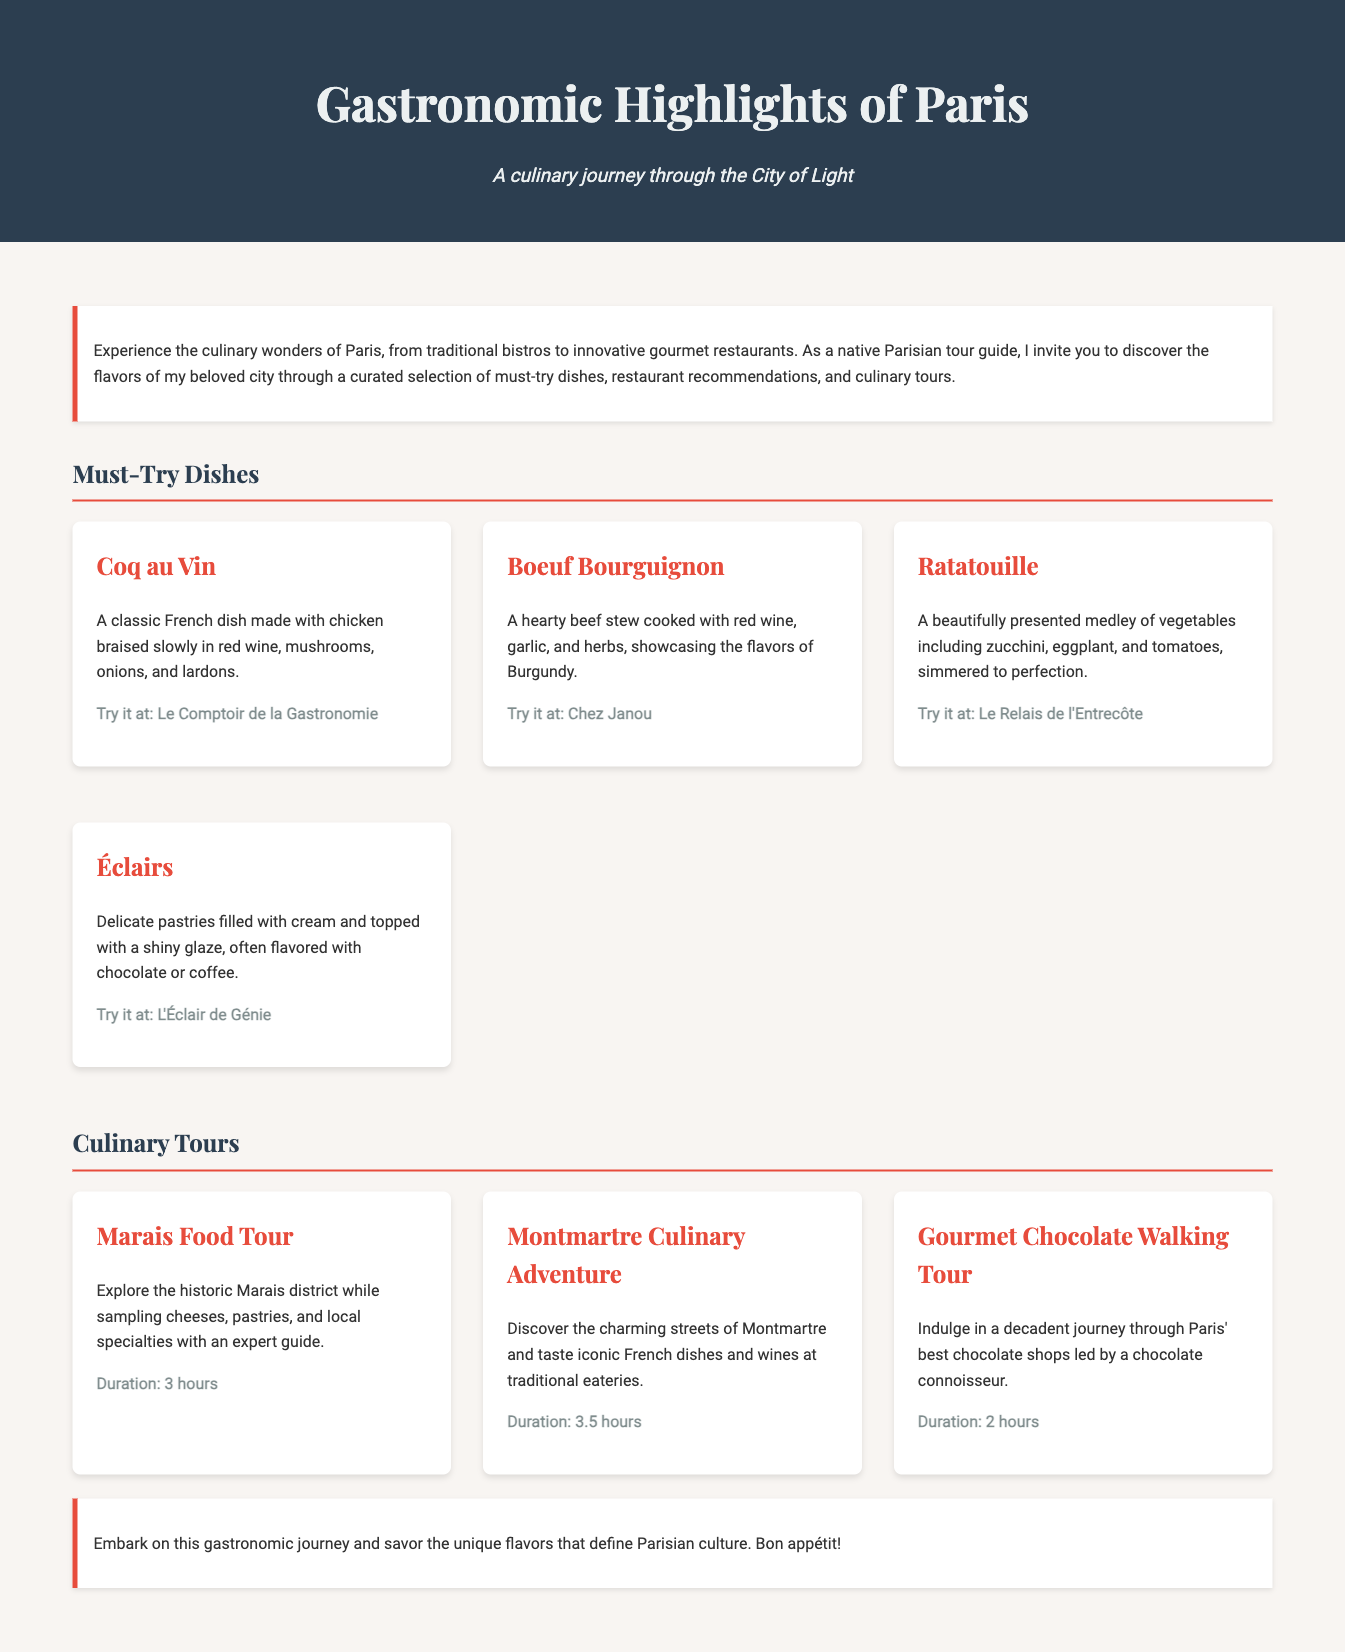What is the title of the document? The title of the document is indicated at the top and is "Gastronomic Highlights of Paris."
Answer: Gastronomic Highlights of Paris What dish is recommended at Le Comptoir de la Gastronomie? The dish recommended at Le Comptoir de la Gastronomie is mentioned as "Coq au Vin."
Answer: Coq au Vin How long is the Montmartre Culinary Adventure tour? The length of the Montmartre Culinary Adventure tour is explicitly stated in the document as "3.5 hours."
Answer: 3.5 hours What type of tour explores the Marais district? The type of tour that explores the Marais district is specified as the "Marais Food Tour."
Answer: Marais Food Tour Which dish includes eggplant and tomatoes? The dish that includes eggplant and tomatoes is described as "Ratatouille."
Answer: Ratatouille What is the duration of the Gourmet Chocolate Walking Tour? The duration of the Gourmet Chocolate Walking Tour is given as "2 hours."
Answer: 2 hours What pastry is filled with cream and topped with glaze? The pastry filled with cream and topped with glaze is identified as "Éclairs."
Answer: Éclairs What is the unique local specialty highlighted in the Montmartre tour? The unique local specialty highlighted in the Montmartre tour refers to "iconic French dishes."
Answer: iconic French dishes 